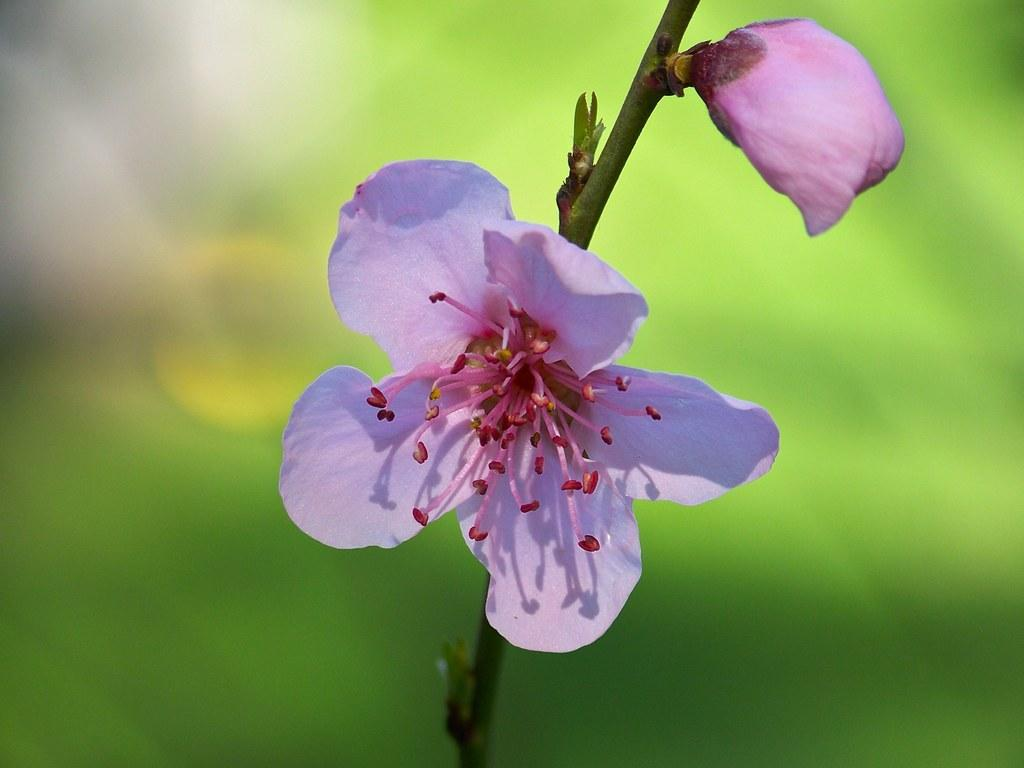How many flowers are in the image? There are two flowers in the image. What color are the flowers? The flowers are pink in color. Where are the flowers located in the image? The flowers are on the stem of a plant. Who is the owner of the dock where the flowers are growing? There is no dock present in the image, and therefore no owner can be identified. 